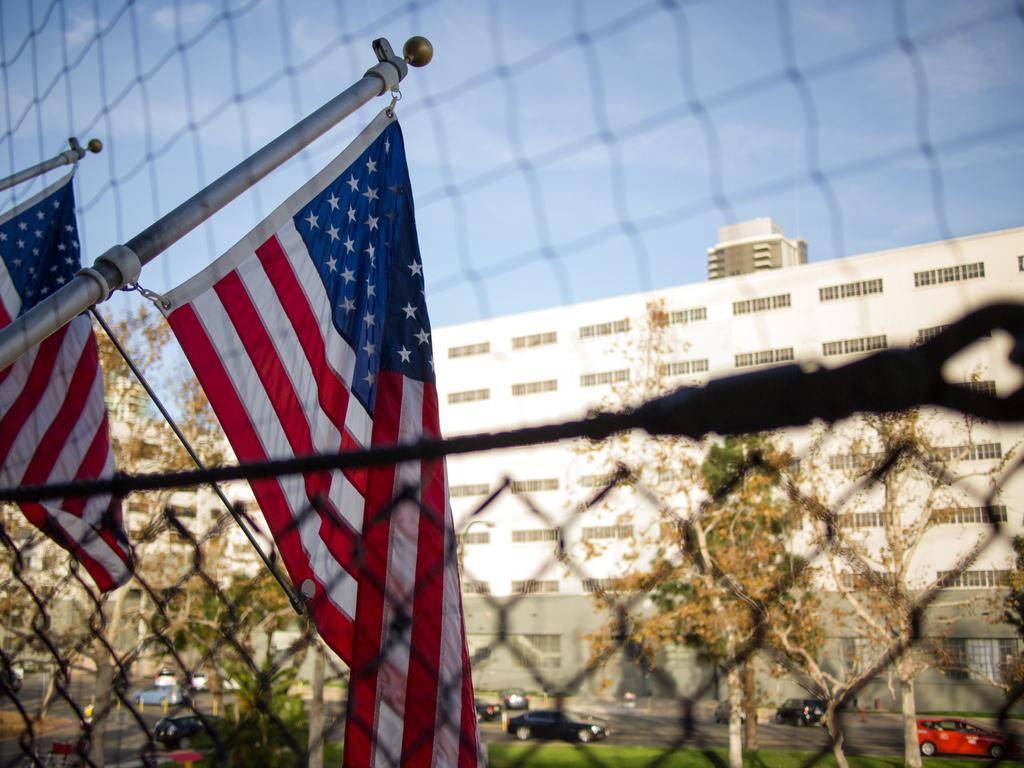What is present in the image that can be used for tying or hanging? There is a rope in the image that can be used for tying or hanging. What can be seen flying in the image? There are flags in the image that can be seen flying. What type of barrier is visible in the image? There is a fence in the image that serves as a barrier. What type of vegetation is visible in the image? There are trees in the image, which are a type of vegetation. What type of structures are visible in the image? There are buildings in the image, which are man-made structures. What type of transportation is visible in the image? Vehicles are passing on the road in the image, which is a form of transportation. What type of ground cover is visible in the image? There is grass visible in the image, which is a type of ground cover. What part of the natural environment is visible in the image? The sky is visible in the image, which is part of the natural environment. Where is the letter being written in the image? There is no letter being written in the image. What type of animal can be seen grazing in the grass in the image? There are no animals visible in the image, let alone grazing in the grass. 